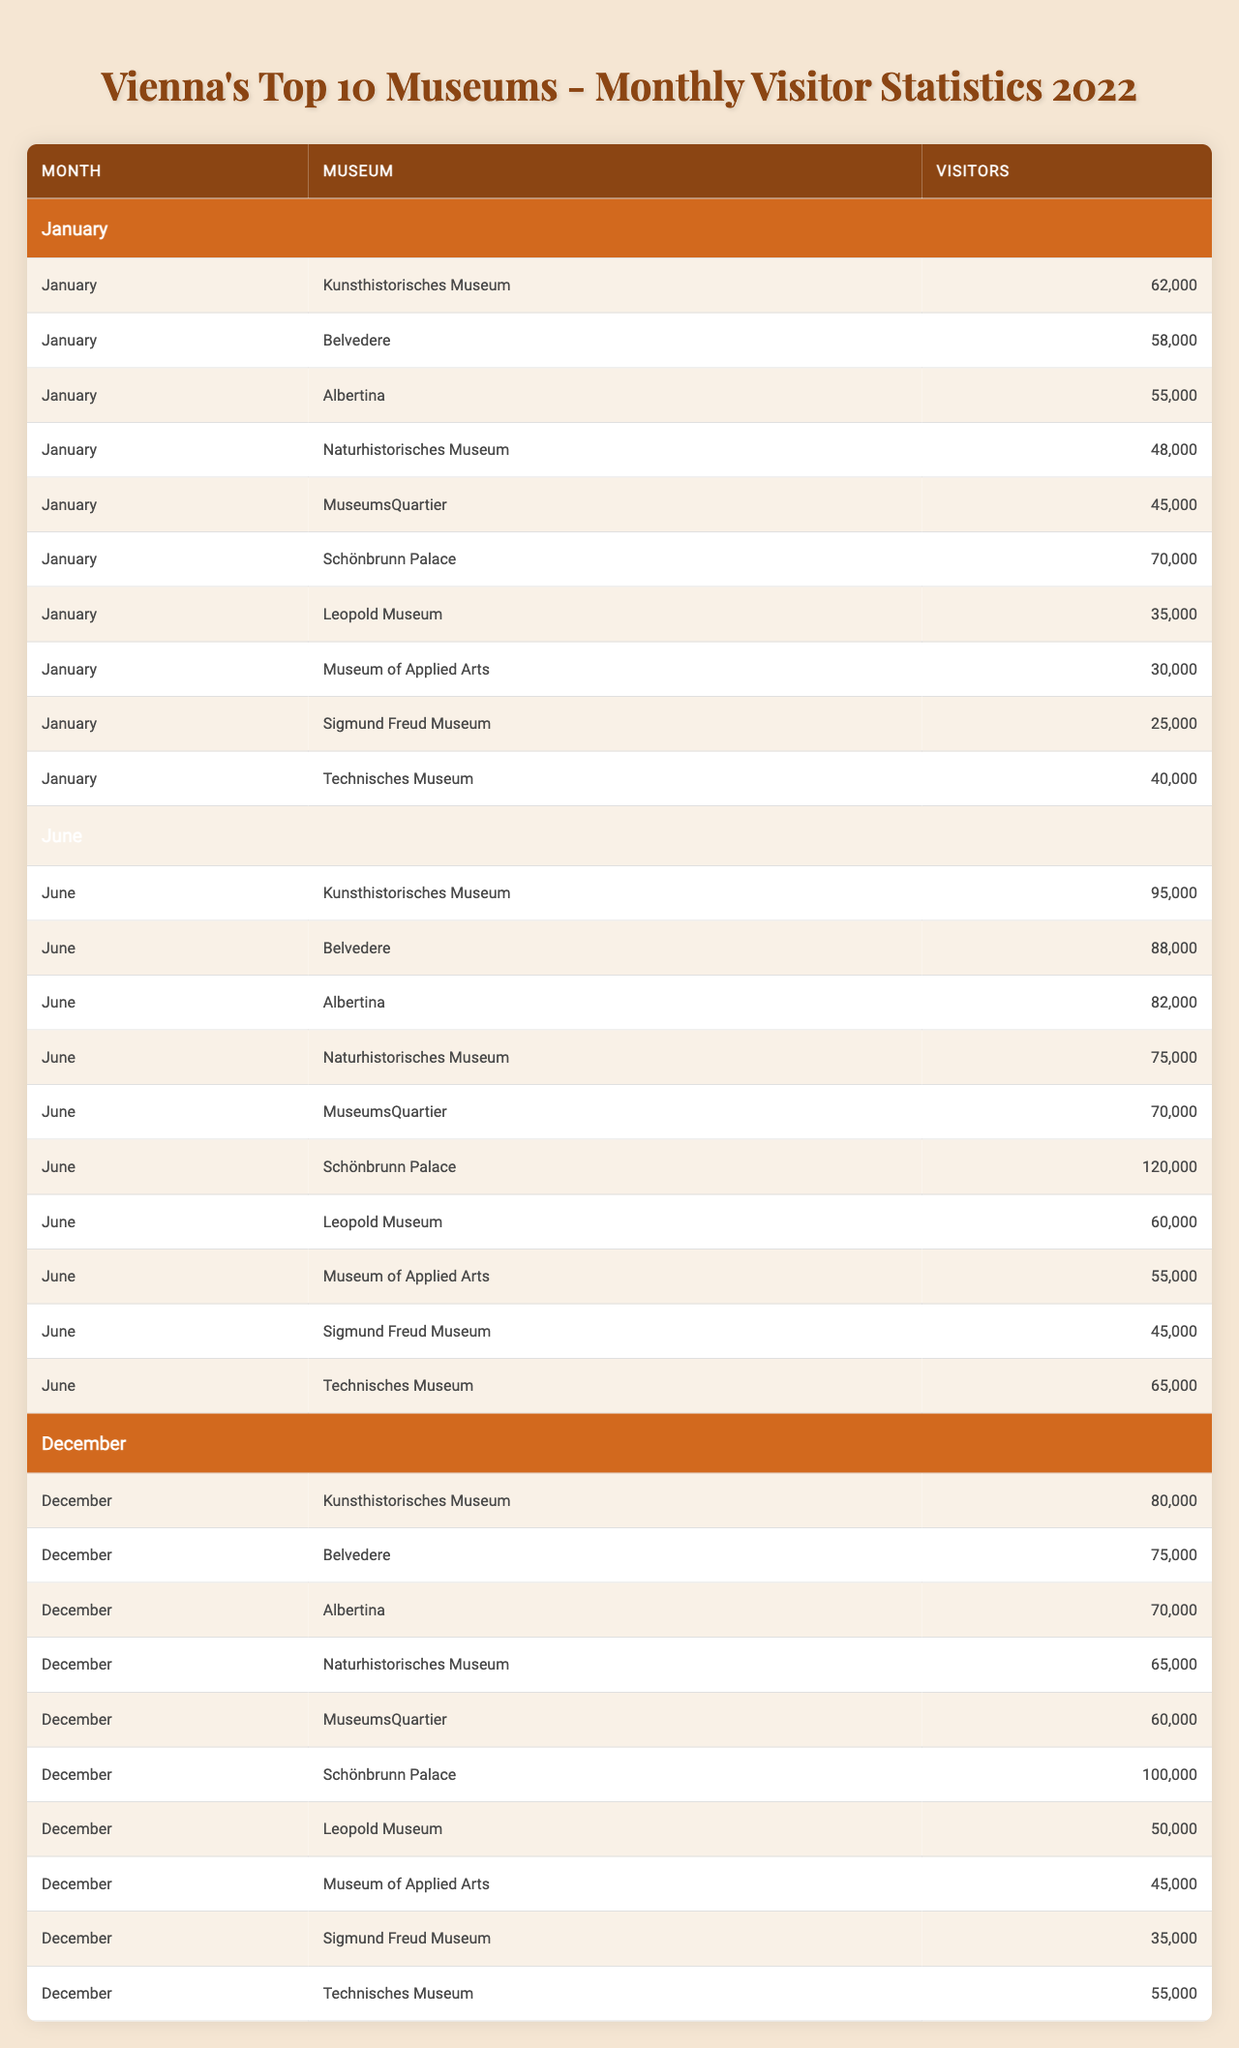What's the total number of visitors to Schönbrunn Palace in December? The table shows that Schönbrunn Palace had 100,000 visitors in December. Therefore, the total number of visitors for this month specifically is 100,000.
Answer: 100,000 Which museum had the highest visitor count in June? In June, the table indicates that Schönbrunn Palace received 120,000 visitors, which is the highest number compared to all other museums in that month.
Answer: Schönbrunn Palace What is the average number of visitors for the Albertina across all months? The visitor counts for Albertina are 55,000 (January), 82,000 (June), and 70,000 (December). Summing these gives 55,000 + 82,000 + 70,000 = 207,000. There are three data points, so the average is 207,000 / 3 = 69,000.
Answer: 69,000 Did the Leopold Museum have more visitors in June than in January? The table shows that in June, Leopold Museum had 60,000 visitors, while in January it had 35,000 visitors. Since 60,000 is greater than 35,000, the statement is true.
Answer: Yes What is the difference in visitor count for the Technisches Museum between January and December? In January, Technisches Museum had 40,000 visitors, and in December it had 55,000 visitors. The difference is calculated as 55,000 - 40,000 = 15,000, indicating Technisches Museum had 15,000 more visitors in December.
Answer: 15,000 Which month had the lowest total visitor count across all museums? To find this, we add the visitor counts for each museum in January (62000 + 58000 + 55000 + 48000 + 45000 + 70000 + 35000 + 30000 + 25000 + 40000 = 2,710,000) and compare it with June and December. The visitor count for June totals 610,000 and for December totals 670,000, so January has the lowest count of 271,000.
Answer: January How many visitors did the Naturhistorisches Museum have in June and December combined? The Naturhistorisches Museum had 75,000 visitors in June and 65,000 in December. Adding these two numbers gives 75,000 + 65,000 = 140,000 for the combined total.
Answer: 140,000 Was the Sigmund Freud Museum ever the most visited museum in any month? Looking at the data, Sigmund Freud Museum had 25,000 visitors in January, 45,000 in June, and 35,000 in December. None of these values surpass the highest counts of other museums; therefore, the answer is no.
Answer: No What is the total number of visitors across all museums in June? The visitor counts for June are: Kunsthistorisches Museum (95,000), Belvedere (88,000), Albertina (82,000), Naturhistorisches Museum (75,000), MuseumsQuartier (70,000), Schönbrunn Palace (120,000), Leopold Museum (60,000), Museum of Applied Arts (55,000), Sigmund Freud Museum (45,000), Technisches Museum (65,000). Adding these gives a total of 95,000 + 88,000 + 82,000 + 75,000 + 70,000 + 120,000 + 60,000 + 55,000 + 45,000 + 65,000 = 765,000.
Answer: 765,000 Which museum consistently received over 40,000 visitors every month? By examining each month's data, it is clear that Schönbrunn Palace, Kunsthistorisches Museum, and Belvedere received over 40,000 visitors in every month listed. Therefore, these museums consistently meet that requirement.
Answer: Schönbrunn Palace, Kunsthistorisches Museum, Belvedere 